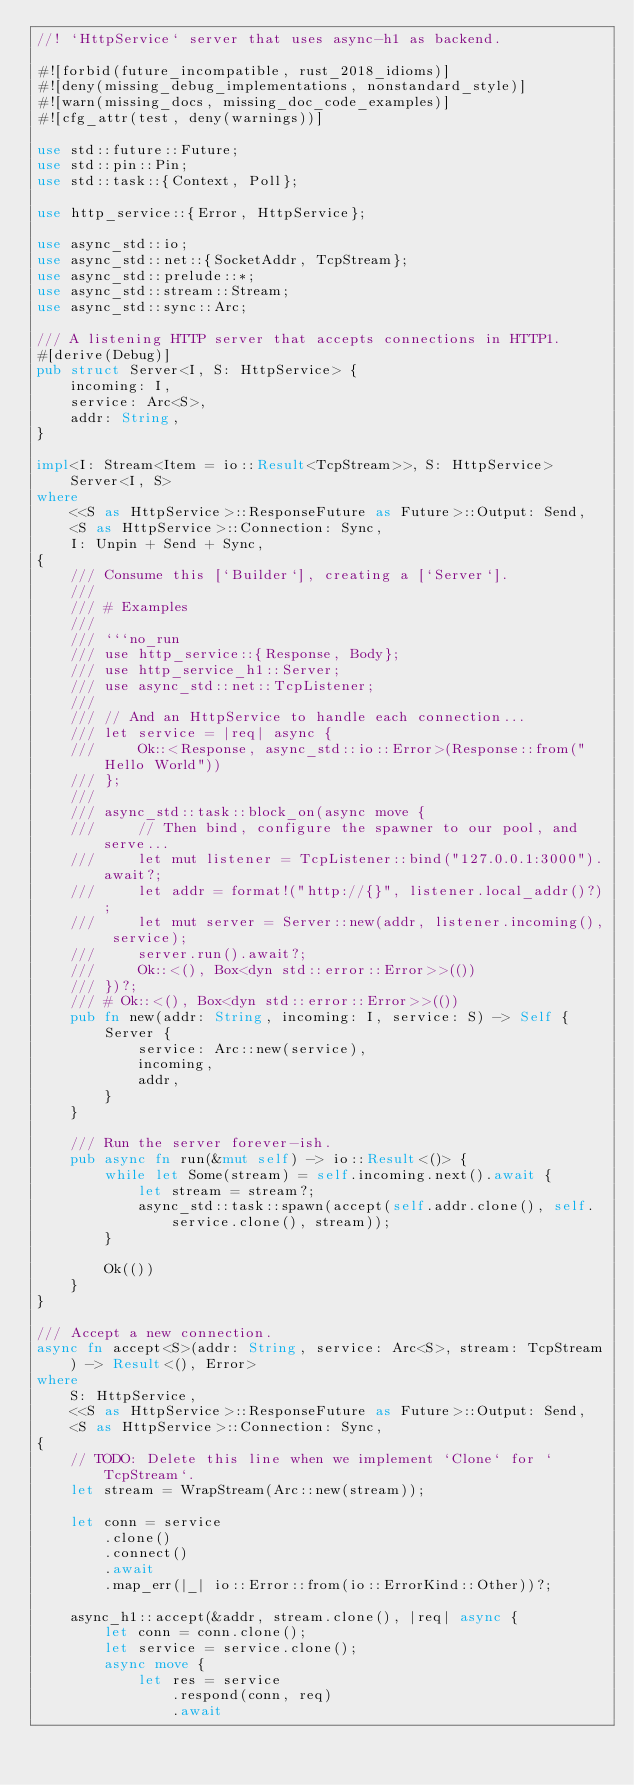<code> <loc_0><loc_0><loc_500><loc_500><_Rust_>//! `HttpService` server that uses async-h1 as backend.

#![forbid(future_incompatible, rust_2018_idioms)]
#![deny(missing_debug_implementations, nonstandard_style)]
#![warn(missing_docs, missing_doc_code_examples)]
#![cfg_attr(test, deny(warnings))]

use std::future::Future;
use std::pin::Pin;
use std::task::{Context, Poll};

use http_service::{Error, HttpService};

use async_std::io;
use async_std::net::{SocketAddr, TcpStream};
use async_std::prelude::*;
use async_std::stream::Stream;
use async_std::sync::Arc;

/// A listening HTTP server that accepts connections in HTTP1.
#[derive(Debug)]
pub struct Server<I, S: HttpService> {
    incoming: I,
    service: Arc<S>,
    addr: String,
}

impl<I: Stream<Item = io::Result<TcpStream>>, S: HttpService> Server<I, S>
where
    <<S as HttpService>::ResponseFuture as Future>::Output: Send,
    <S as HttpService>::Connection: Sync,
    I: Unpin + Send + Sync,
{
    /// Consume this [`Builder`], creating a [`Server`].
    ///
    /// # Examples
    ///
    /// ```no_run
    /// use http_service::{Response, Body};
    /// use http_service_h1::Server;
    /// use async_std::net::TcpListener;
    ///
    /// // And an HttpService to handle each connection...
    /// let service = |req| async {
    ///     Ok::<Response, async_std::io::Error>(Response::from("Hello World"))
    /// };
    ///
    /// async_std::task::block_on(async move {
    ///     // Then bind, configure the spawner to our pool, and serve...
    ///     let mut listener = TcpListener::bind("127.0.0.1:3000").await?;
    ///     let addr = format!("http://{}", listener.local_addr()?);
    ///     let mut server = Server::new(addr, listener.incoming(), service);
    ///     server.run().await?;
    ///     Ok::<(), Box<dyn std::error::Error>>(())
    /// })?;
    /// # Ok::<(), Box<dyn std::error::Error>>(())
    pub fn new(addr: String, incoming: I, service: S) -> Self {
        Server {
            service: Arc::new(service),
            incoming,
            addr,
        }
    }

    /// Run the server forever-ish.
    pub async fn run(&mut self) -> io::Result<()> {
        while let Some(stream) = self.incoming.next().await {
            let stream = stream?;
            async_std::task::spawn(accept(self.addr.clone(), self.service.clone(), stream));
        }

        Ok(())
    }
}

/// Accept a new connection.
async fn accept<S>(addr: String, service: Arc<S>, stream: TcpStream) -> Result<(), Error>
where
    S: HttpService,
    <<S as HttpService>::ResponseFuture as Future>::Output: Send,
    <S as HttpService>::Connection: Sync,
{
    // TODO: Delete this line when we implement `Clone` for `TcpStream`.
    let stream = WrapStream(Arc::new(stream));

    let conn = service
        .clone()
        .connect()
        .await
        .map_err(|_| io::Error::from(io::ErrorKind::Other))?;

    async_h1::accept(&addr, stream.clone(), |req| async {
        let conn = conn.clone();
        let service = service.clone();
        async move {
            let res = service
                .respond(conn, req)
                .await</code> 